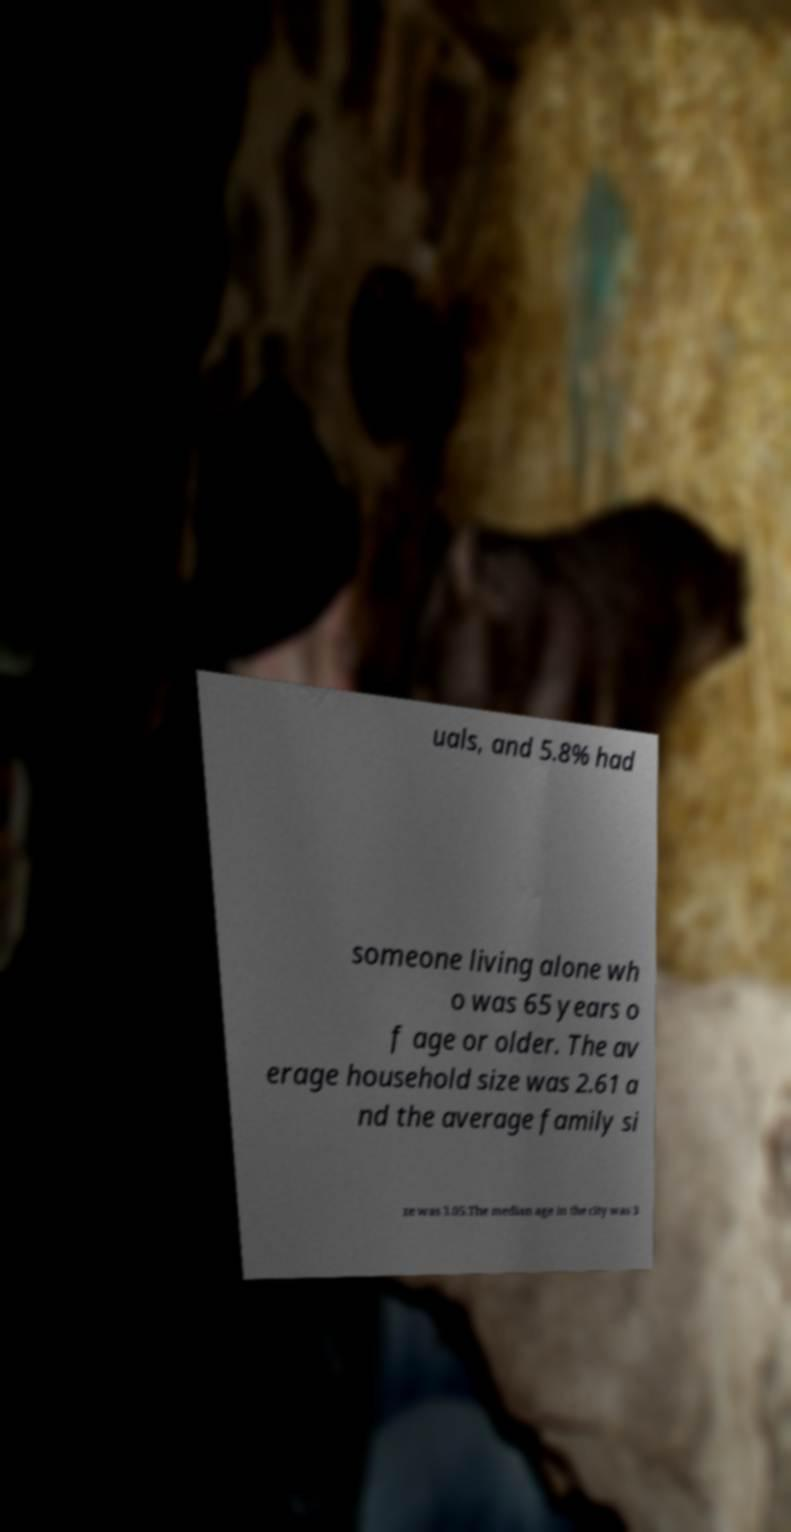Could you extract and type out the text from this image? uals, and 5.8% had someone living alone wh o was 65 years o f age or older. The av erage household size was 2.61 a nd the average family si ze was 3.05.The median age in the city was 3 